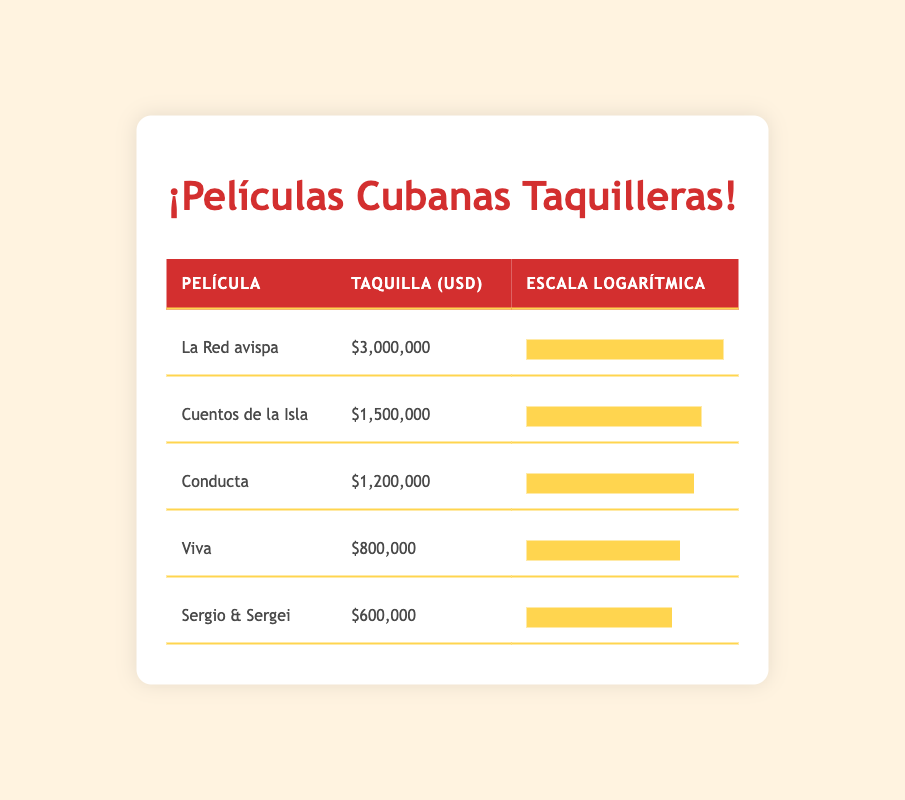What is the box office revenue for the film "La Red avispa"? The table shows the box office revenue for each film. For "La Red avispa," the revenue listed is $3,000,000.
Answer: $3,000,000 Which film has the highest box office revenue? By reviewing the revenue figures, "La Red avispa," with $3,000,000, has the highest box office revenue compared to the others listed.
Answer: La Red avispa What is the total box office revenue of all the films combined? To find the total revenue, we sum the revenues of all films: 3,000,000 + 1,500,000 + 1,200,000 + 800,000 + 600,000 = 7,100,000.
Answer: $7,100,000 Is "Cuentos de la Isla" among the top three highest-grossing films? "Cuentos de la Isla" has a revenue of $1,500,000, which ranks second overall, thus confirming that it is in the top three.
Answer: Yes How much more did "La Red avispa" earn compared to "Sergio & Sergei"? To find the difference, we subtract the revenue of "Sergio & Sergei" ($600,000) from "La Red avispa" ($3,000,000): 3,000,000 - 600,000 = 2,400,000.
Answer: $2,400,000 What is the average box office revenue of the films listed? To calculate the average, we take the total revenue ($7,100,000) and divide it by the number of films (5): 7,100,000 / 5 = 1,420,000.
Answer: $1,420,000 Does "Viva" have a box office revenue greater than $1,000,000? The revenue for "Viva" is listed as $800,000, which is less than $1,000,000, making the answer no.
Answer: No Which film had a box office revenue closest to $1,000,000? Looking at the revenues, "Conducta" is $1,200,000 and is the closest to $1,000,000, while "Viva" at $800,000 is further away.
Answer: Conducta 